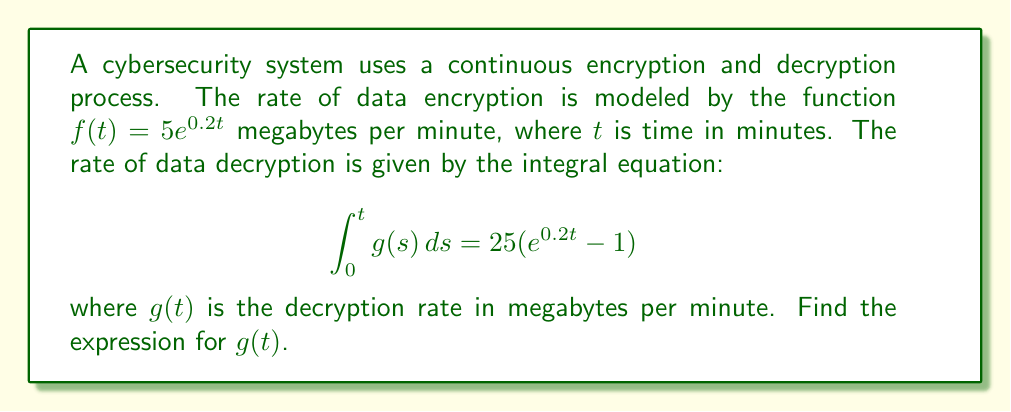What is the answer to this math problem? To solve this integral equation, we'll follow these steps:

1) First, we recognize that the right-hand side of the equation is a function of $t$. Let's call this function $F(t)$:

   $$F(t) = 25(e^{0.2t} - 1)$$

2) The left-hand side of the equation is a definite integral of $g(s)$ from 0 to $t$. This is equivalent to an indefinite integral of $g(t)$ evaluated at $t$ minus the same integral evaluated at 0:

   $$\int_0^t g(s) ds = \int g(t) dt \bigg|_0^t = G(t) - G(0)$$

   where $G(t)$ is an antiderivative of $g(t)$.

3) Therefore, we can write:

   $$G(t) - G(0) = F(t)$$

4) To find $g(t)$, we need to differentiate both sides with respect to $t$:

   $$\frac{d}{dt}[G(t) - G(0)] = \frac{d}{dt}F(t)$$

5) The left-hand side simplifies to $g(t)$ (since $G(0)$ is a constant), and we can compute the derivative of the right-hand side:

   $$g(t) = \frac{d}{dt}[25(e^{0.2t} - 1)] = 25 \cdot 0.2e^{0.2t} = 5e^{0.2t}$$

Thus, we have found the expression for $g(t)$.
Answer: $g(t) = 5e^{0.2t}$ 